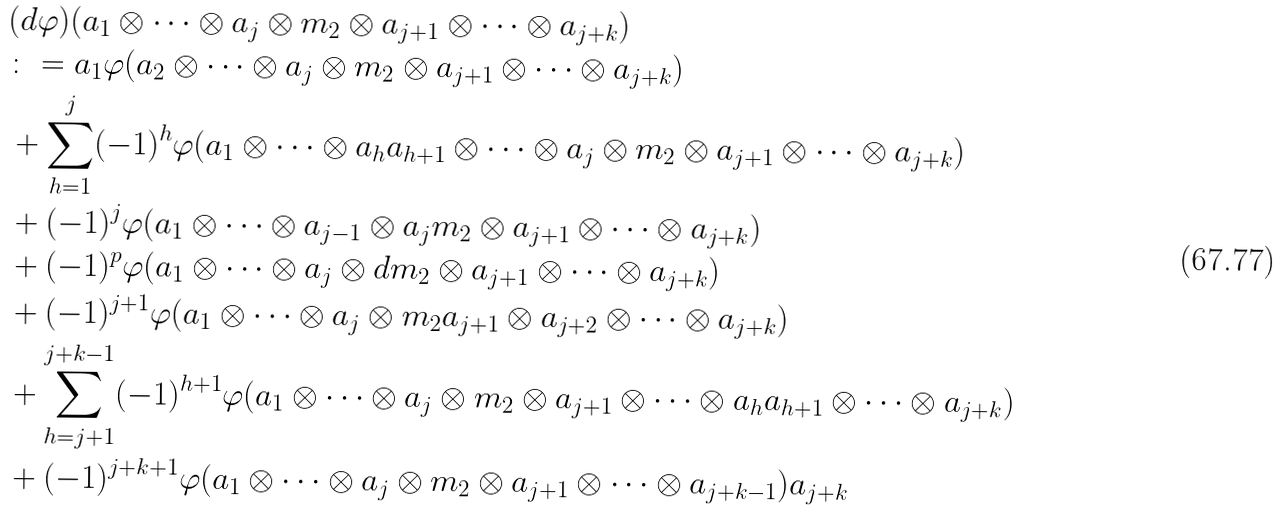Convert formula to latex. <formula><loc_0><loc_0><loc_500><loc_500>& ( d \varphi ) ( a _ { 1 } \otimes \cdots \otimes a _ { j } \otimes m _ { 2 } \otimes a _ { j + 1 } \otimes \cdots \otimes a _ { j + k } ) \\ & \colon = a _ { 1 } \varphi ( a _ { 2 } \otimes \cdots \otimes a _ { j } \otimes m _ { 2 } \otimes a _ { j + 1 } \otimes \cdots \otimes a _ { j + k } ) \\ & + \sum _ { h = 1 } ^ { j } ( - 1 ) ^ { h } \varphi ( a _ { 1 } \otimes \cdots \otimes a _ { h } a _ { h + 1 } \otimes \cdots \otimes a _ { j } \otimes m _ { 2 } \otimes a _ { j + 1 } \otimes \cdots \otimes a _ { j + k } ) \\ & + ( - 1 ) ^ { j } \varphi ( a _ { 1 } \otimes \cdots \otimes a _ { j - 1 } \otimes a _ { j } m _ { 2 } \otimes a _ { j + 1 } \otimes \cdots \otimes a _ { j + k } ) \\ & + ( - 1 ) ^ { p } \varphi ( a _ { 1 } \otimes \cdots \otimes a _ { j } \otimes d m _ { 2 } \otimes a _ { j + 1 } \otimes \cdots \otimes a _ { j + k } ) \\ & + ( - 1 ) ^ { j + 1 } \varphi ( a _ { 1 } \otimes \cdots \otimes a _ { j } \otimes m _ { 2 } a _ { j + 1 } \otimes a _ { j + 2 } \otimes \cdots \otimes a _ { j + k } ) \\ & + \sum _ { h = j + 1 } ^ { j + k - 1 } ( - 1 ) ^ { h + 1 } \varphi ( a _ { 1 } \otimes \cdots \otimes a _ { j } \otimes m _ { 2 } \otimes a _ { j + 1 } \otimes \cdots \otimes a _ { h } a _ { h + 1 } \otimes \cdots \otimes a _ { j + k } ) \\ & + ( - 1 ) ^ { j + k + 1 } \varphi ( a _ { 1 } \otimes \cdots \otimes a _ { j } \otimes m _ { 2 } \otimes a _ { j + 1 } \otimes \cdots \otimes a _ { j + k - 1 } ) a _ { j + k }</formula> 